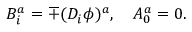Convert formula to latex. <formula><loc_0><loc_0><loc_500><loc_500>B _ { i } ^ { a } = \mp ( D _ { i } \phi ) ^ { a } , \quad A _ { 0 } ^ { a } = 0 .</formula> 